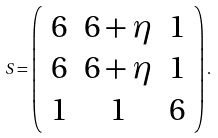<formula> <loc_0><loc_0><loc_500><loc_500>S = \left ( \begin{array} { c c c } 6 & 6 + \eta & 1 \\ 6 & 6 + \eta & 1 \\ 1 & 1 & 6 \\ \end{array} \right ) .</formula> 